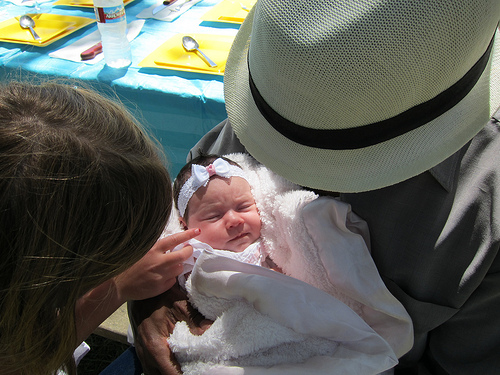<image>
Is there a father on the baby? No. The father is not positioned on the baby. They may be near each other, but the father is not supported by or resting on top of the baby. Is there a baby to the left of the man? No. The baby is not to the left of the man. From this viewpoint, they have a different horizontal relationship. Is the baby under the hat? Yes. The baby is positioned underneath the hat, with the hat above it in the vertical space. Is the bottle in front of the baby? No. The bottle is not in front of the baby. The spatial positioning shows a different relationship between these objects. 